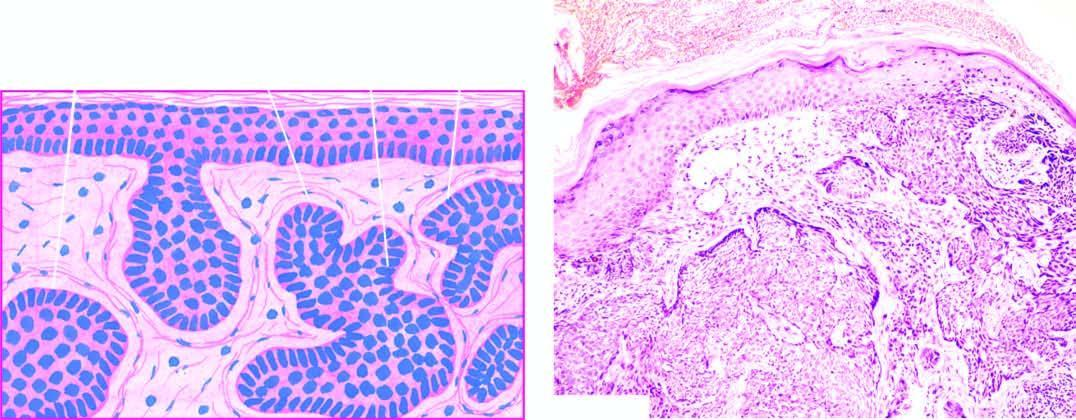what are separated from dermal collagen by a space called shrinkage artefact?
Answer the question using a single word or phrase. Masses of tumour cells 